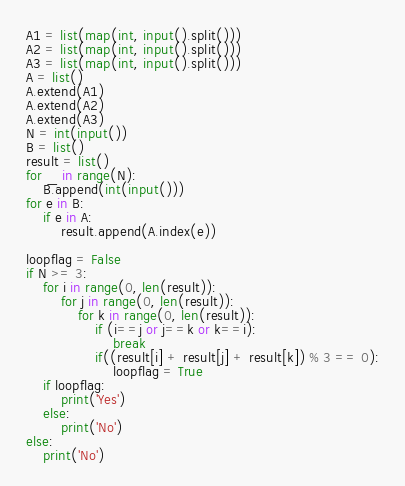Convert code to text. <code><loc_0><loc_0><loc_500><loc_500><_Python_>A1 = list(map(int, input().split()))
A2 = list(map(int, input().split()))
A3 = list(map(int, input().split()))
A = list()
A.extend(A1)
A.extend(A2)
A.extend(A3)
N = int(input())
B = list()
result = list()
for _ in range(N):
    B.append(int(input()))
for e in B:
    if e in A:
        result.append(A.index(e))

loopflag = False
if N >= 3:
    for i in range(0, len(result)):
        for j in range(0, len(result)):
            for k in range(0, len(result)):
                if (i==j or j==k or k==i):
                    break
                if((result[i] + result[j] + result[k]) % 3 == 0):
                    loopflag = True
    if loopflag:
        print('Yes')
    else:
        print('No')
else:
    print('No')</code> 